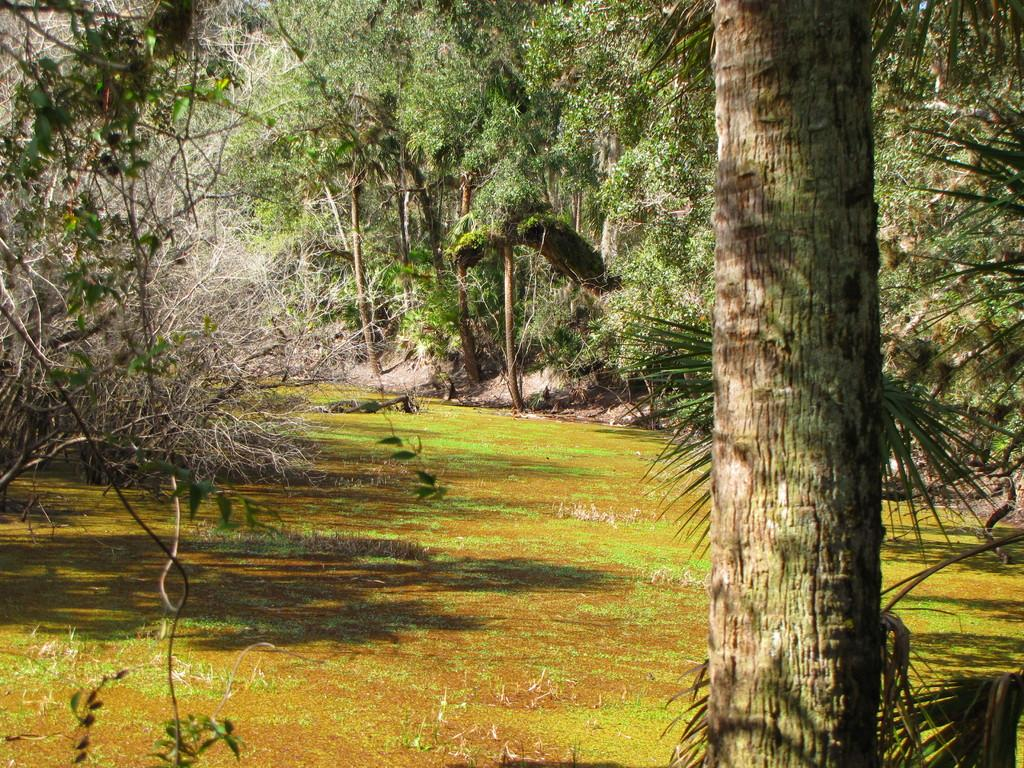What object is located on the right side of the image? There is a trunk on the right side of the image. What type of natural environment is depicted in the image? There are trees around the area of the image, indicating a forest or wooded area. Where is the desk located in the image? There is no desk present in the image. What type of lighting is provided by the bulb in the image? There is no bulb present in the image. 